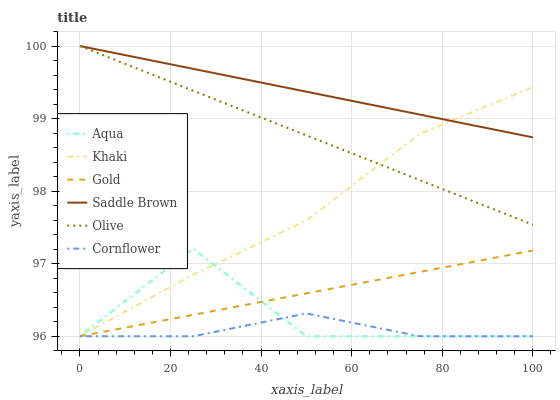Does Cornflower have the minimum area under the curve?
Answer yes or no. Yes. Does Saddle Brown have the maximum area under the curve?
Answer yes or no. Yes. Does Khaki have the minimum area under the curve?
Answer yes or no. No. Does Khaki have the maximum area under the curve?
Answer yes or no. No. Is Olive the smoothest?
Answer yes or no. Yes. Is Aqua the roughest?
Answer yes or no. Yes. Is Khaki the smoothest?
Answer yes or no. No. Is Khaki the roughest?
Answer yes or no. No. Does Olive have the lowest value?
Answer yes or no. No. Does Saddle Brown have the highest value?
Answer yes or no. Yes. Does Khaki have the highest value?
Answer yes or no. No. Is Cornflower less than Saddle Brown?
Answer yes or no. Yes. Is Saddle Brown greater than Aqua?
Answer yes or no. Yes. Does Cornflower intersect Saddle Brown?
Answer yes or no. No. 